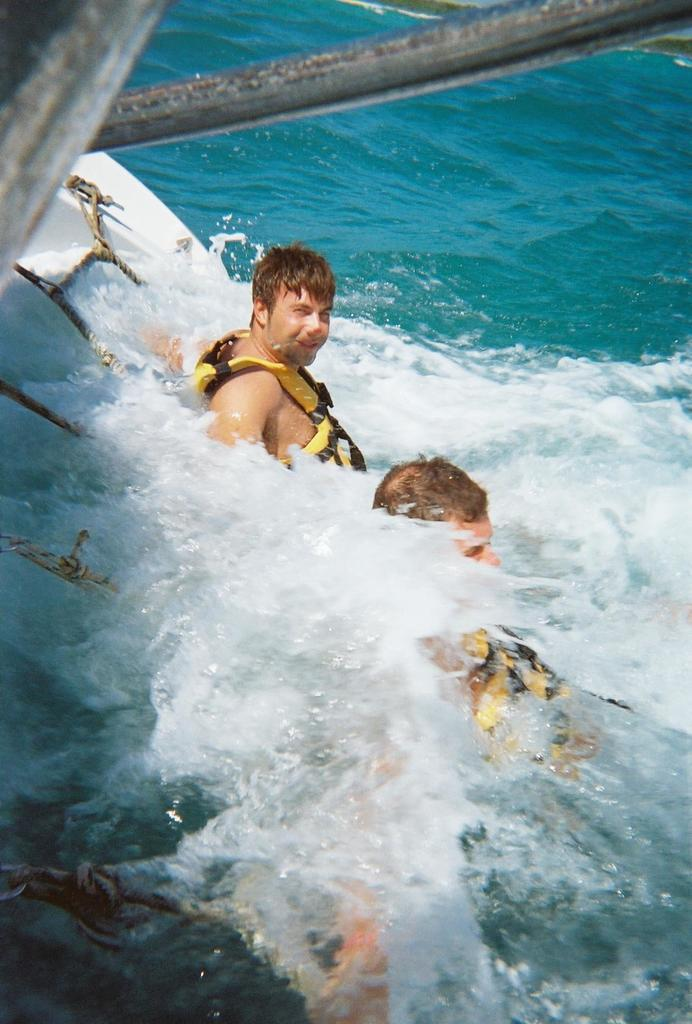How many people are in the water in the image? There are two persons in the water in the image. What is located on the left side of the image? There is a rope net on the left side of the image. What type of material can be seen at the top of the image? There are iron rods visible at the top of the image. What is the profit margin of the market depicted in the image? There is no market or profit margin mentioned in the image; it features two persons in the water and a rope net on the left side. 